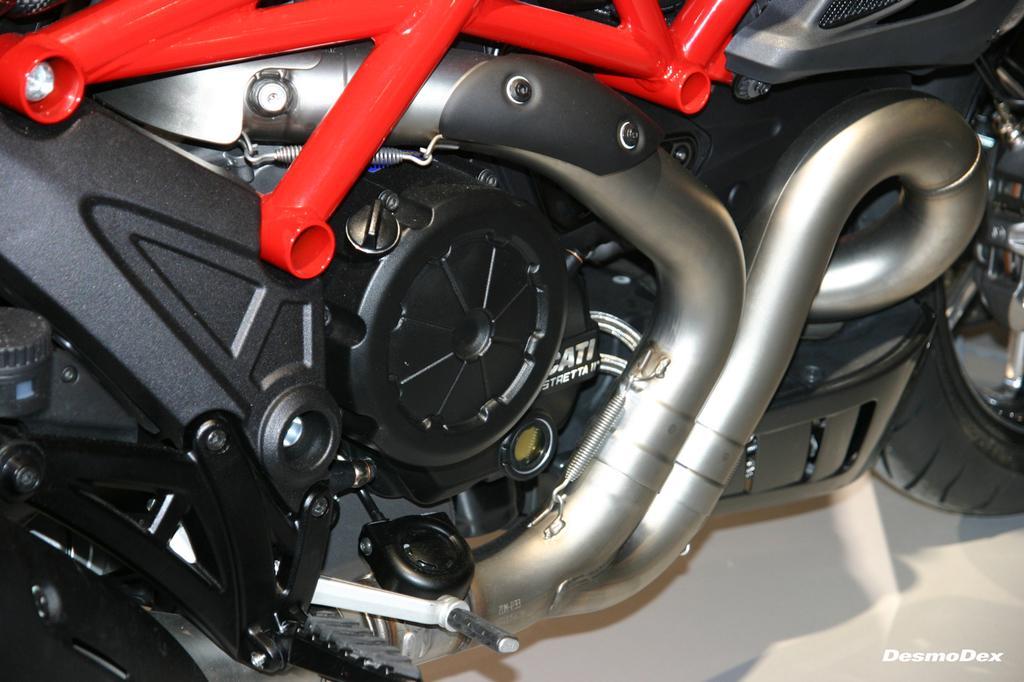Could you give a brief overview of what you see in this image? In the foreground of this image, there is a truncated motor bike on a white surface where we can see kick rod, pedal, tyre and few more parts of it. 